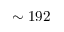<formula> <loc_0><loc_0><loc_500><loc_500>\sim 1 9 2</formula> 